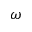<formula> <loc_0><loc_0><loc_500><loc_500>\omega</formula> 